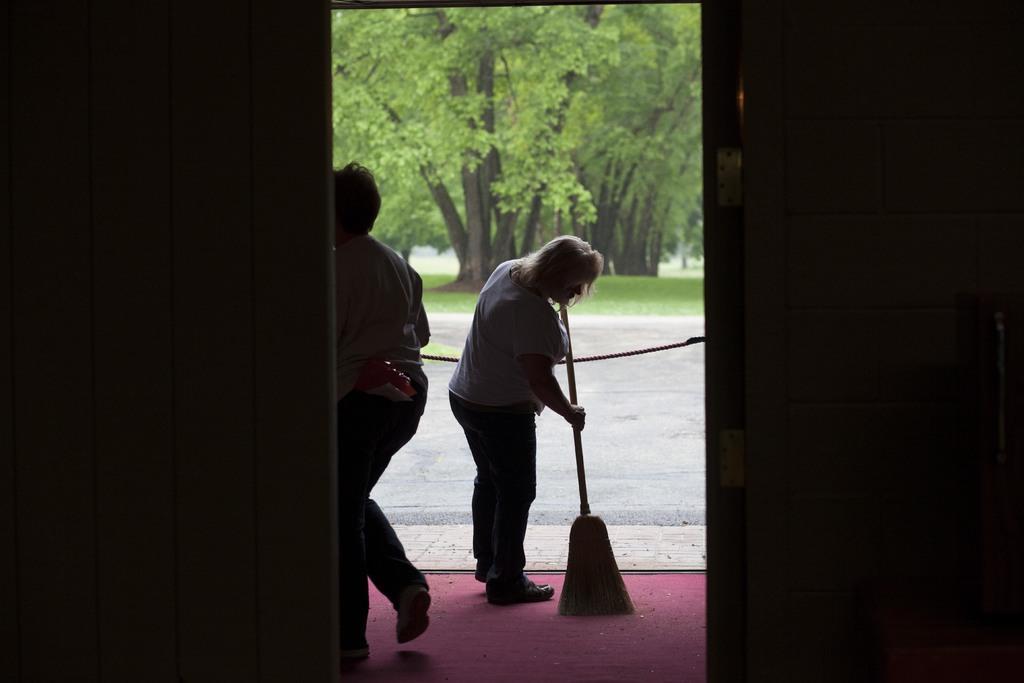Can you describe this image briefly? In the image there is a woman brooming the floor with broom stick and a person walking on the left side, in the back there are trees on the grassland. 